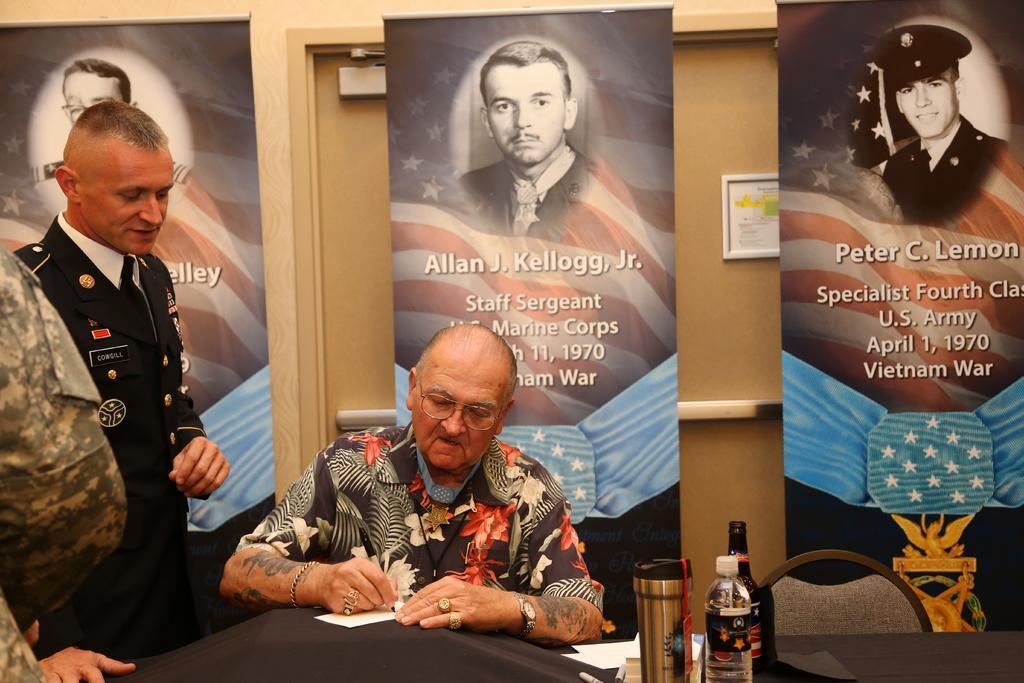Could you give a brief overview of what you see in this image? This image consists of two persons. In the front, the man is sitting in the chair and writing on a paper. In front of him, there is a table covered with black cloth. In the background, there are banners and a door. To the left, the man standing is wearing a black dress. 